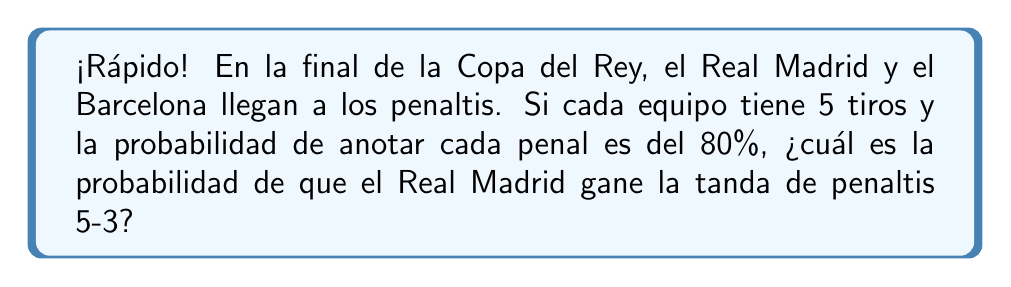Solve this math problem. Vamos paso a paso, ¡como un contraataque rápido!

1) Para que el Real Madrid gane 5-3, necesitan:
   - Real Madrid: anotar los 5 penales
   - Barcelona: anotar 3 y fallar 2 de sus 5 penales

2) Probabilidad de que el Real Madrid anote los 5:
   $P(\text{RM 5}) = 0.8^5 = 0.32768$

3) Probabilidad de que el Barcelona anote exactamente 3 de 5:
   Usamos la distribución binomial:
   $$P(\text{Barça 3}) = \binom{5}{3} \cdot 0.8^3 \cdot 0.2^2$$
   $$= 10 \cdot 0.512 \cdot 0.04 = 0.2048$$

4) La probabilidad total es el producto de estas dos probabilidades independientes:
   $$P(\text{RM gana 5-3}) = P(\text{RM 5}) \cdot P(\text{Barça 3})$$
   $$= 0.32768 \cdot 0.2048 = 0.0671$$

5) Convertimos a porcentaje:
   $0.0671 \cdot 100\% = 6.71\%$

¡Y eso es todo, más rápido que un gol de Vinicius Jr.!
Answer: 6.71% 